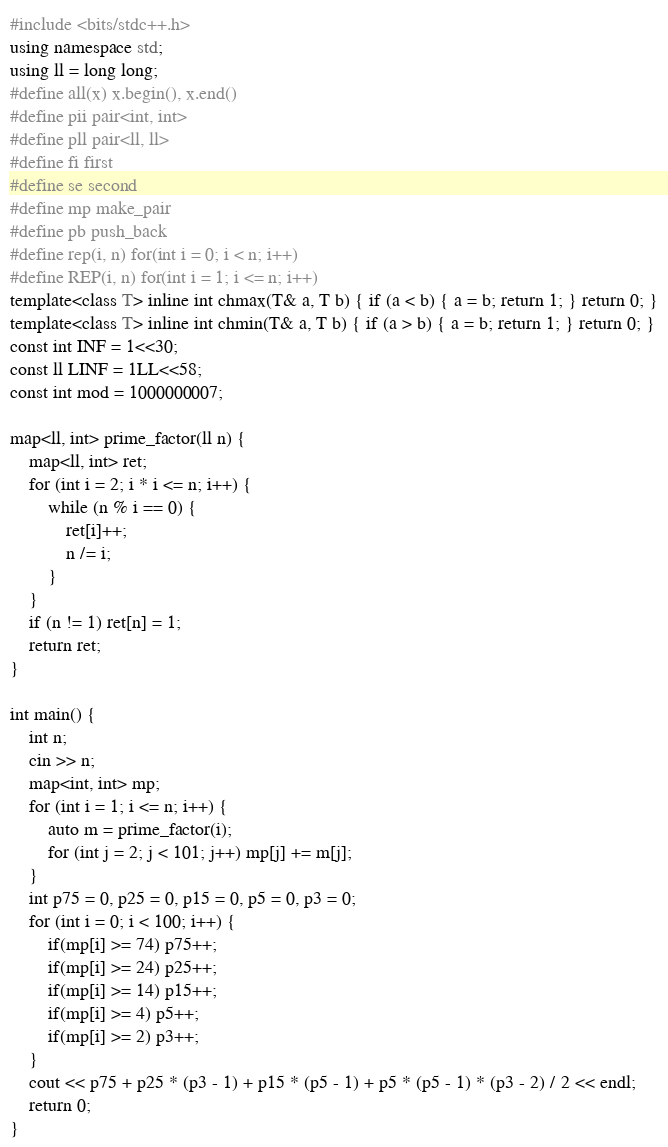<code> <loc_0><loc_0><loc_500><loc_500><_C++_>#include <bits/stdc++.h>
using namespace std;
using ll = long long;
#define all(x) x.begin(), x.end()
#define pii pair<int, int>
#define pll pair<ll, ll>
#define fi first
#define se second
#define mp make_pair
#define pb push_back
#define rep(i, n) for(int i = 0; i < n; i++)
#define REP(i, n) for(int i = 1; i <= n; i++)
template<class T> inline int chmax(T& a, T b) { if (a < b) { a = b; return 1; } return 0; }
template<class T> inline int chmin(T& a, T b) { if (a > b) { a = b; return 1; } return 0; }
const int INF = 1<<30;
const ll LINF = 1LL<<58;
const int mod = 1000000007;

map<ll, int> prime_factor(ll n) {
    map<ll, int> ret;
    for (int i = 2; i * i <= n; i++) {
        while (n % i == 0) {
            ret[i]++;
            n /= i;
        }
    }
    if (n != 1) ret[n] = 1;
    return ret;
}

int main() {
    int n;
    cin >> n;
    map<int, int> mp;
    for (int i = 1; i <= n; i++) {
        auto m = prime_factor(i);
        for (int j = 2; j < 101; j++) mp[j] += m[j];
    }
    int p75 = 0, p25 = 0, p15 = 0, p5 = 0, p3 = 0;
    for (int i = 0; i < 100; i++) {
        if(mp[i] >= 74) p75++;
        if(mp[i] >= 24) p25++;
        if(mp[i] >= 14) p15++;
        if(mp[i] >= 4) p5++;
        if(mp[i] >= 2) p3++;
    }
    cout << p75 + p25 * (p3 - 1) + p15 * (p5 - 1) + p5 * (p5 - 1) * (p3 - 2) / 2 << endl;
    return 0;
}
</code> 